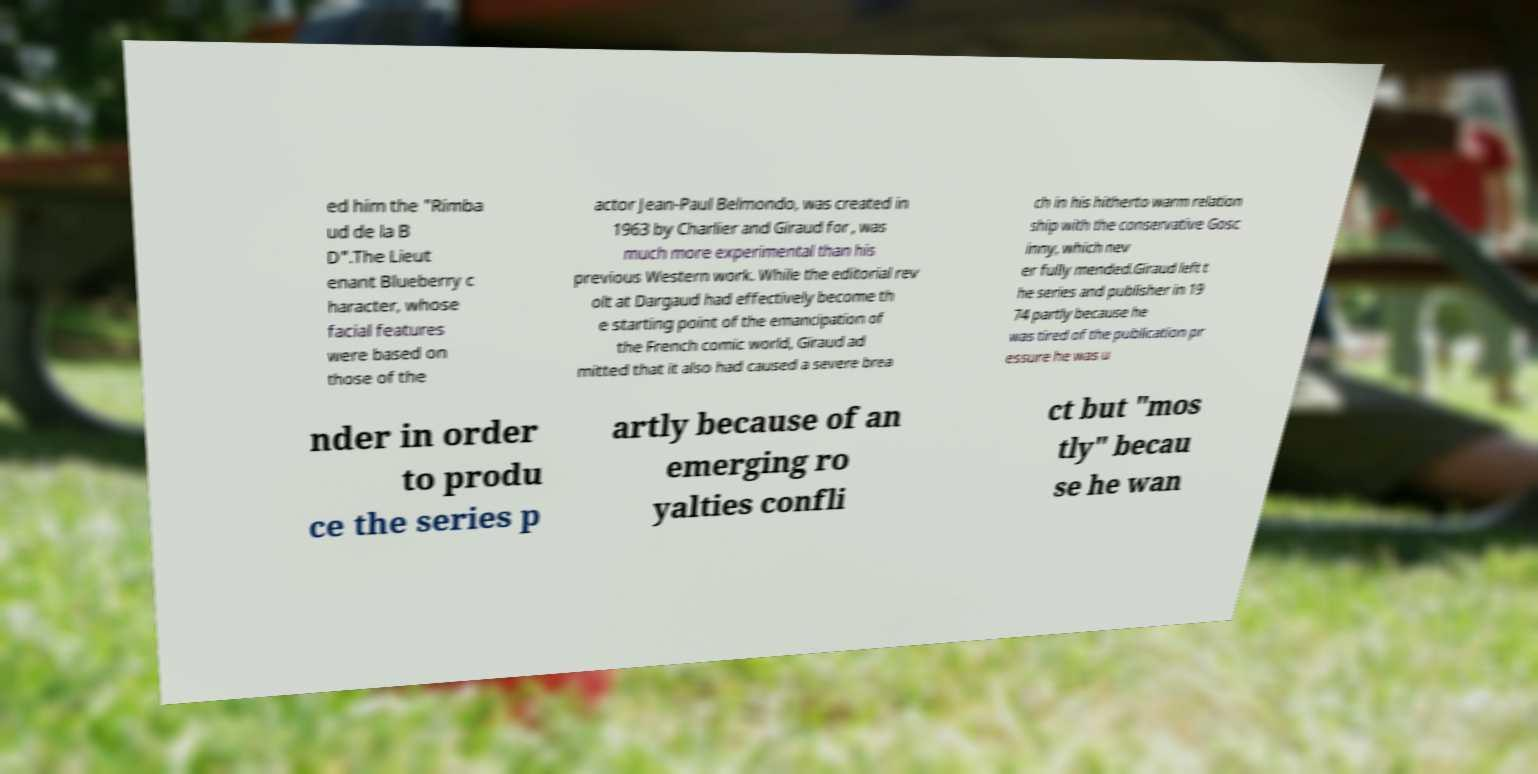Could you assist in decoding the text presented in this image and type it out clearly? ed him the "Rimba ud de la B D".The Lieut enant Blueberry c haracter, whose facial features were based on those of the actor Jean-Paul Belmondo, was created in 1963 by Charlier and Giraud for , was much more experimental than his previous Western work. While the editorial rev olt at Dargaud had effectively become th e starting point of the emancipation of the French comic world, Giraud ad mitted that it also had caused a severe brea ch in his hitherto warm relation ship with the conservative Gosc inny, which nev er fully mended.Giraud left t he series and publisher in 19 74 partly because he was tired of the publication pr essure he was u nder in order to produ ce the series p artly because of an emerging ro yalties confli ct but "mos tly" becau se he wan 